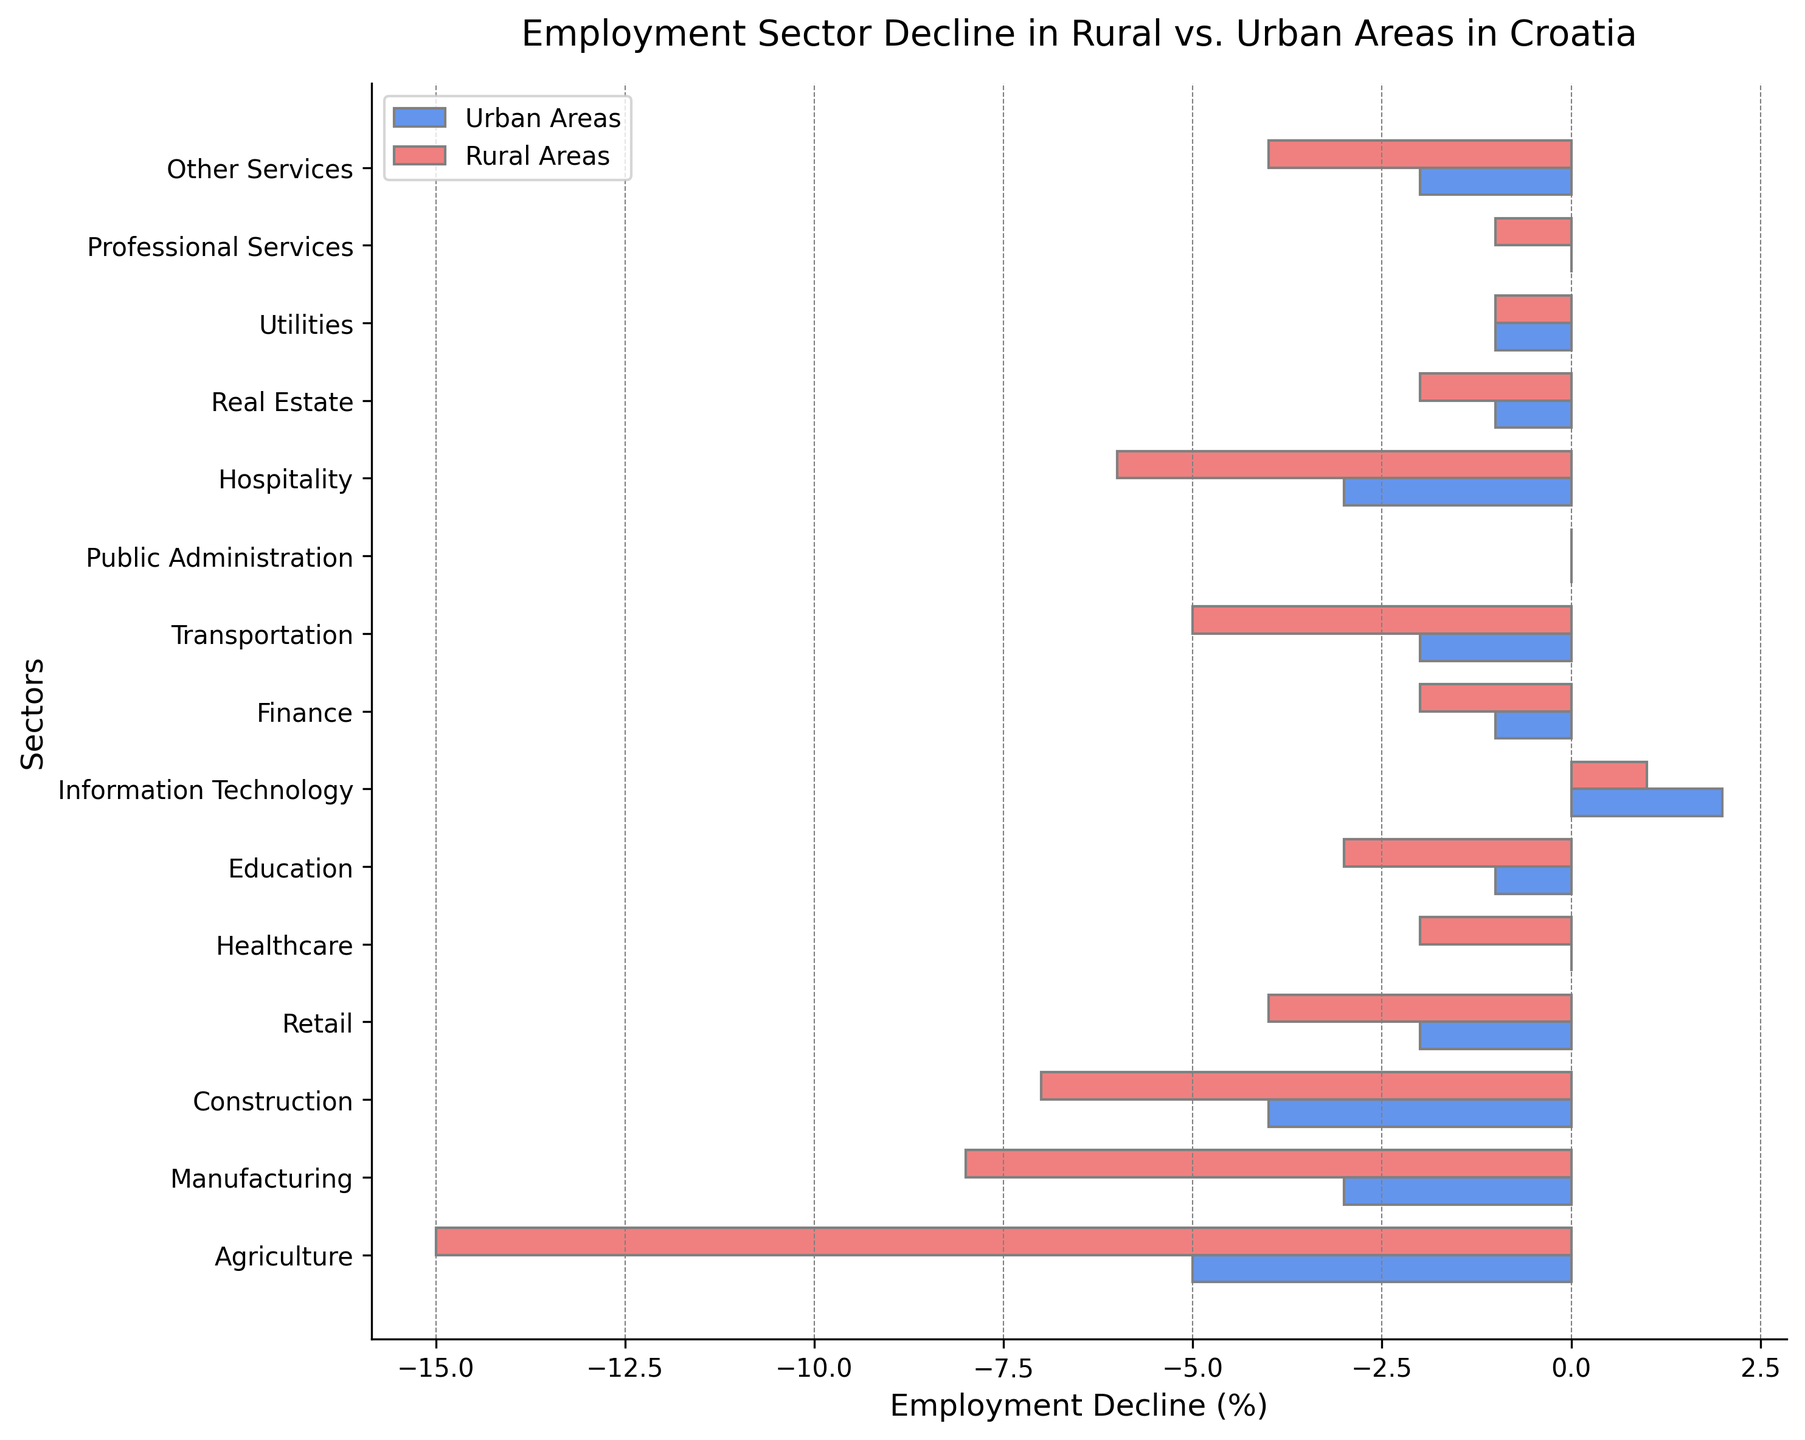What's the total employment decline in Agriculture for both Urban and Rural Areas? To find the total employment decline in Agriculture, add the decline percentages for both Urban and Rural Areas. For Urban Areas, the decline is -5%, and for Rural Areas, the decline is -15%; thus, -5 + (-15) = -20%.
Answer: -20% Which sector has experienced the least decline in Urban Areas and what is its value? In Urban Areas, the sectors with the least (or no) decline are Healthcare, Public Administration, and Information Technology. Healthcare and Public Administration show no decline (0%), but Information Technology shows a positive growth. Thus, they are the sectors with the least decline.
Answer: Healthcare, Public Administration (0%) What is the difference in employment decline between Manufacturing and Construction in Rural Areas? To find the difference in employment decline between Manufacturing and Construction in Rural Areas, subtract the decline of the Construction sector from that of the Manufacturing sector: -8 - (-7) = -8 + 7 = -1%.
Answer: -1% Which sector has shown growth in Information Technology, and what are the growth percentages in Urban and Rural Areas? In the Information Technology sector, there is growth instead of decline. In Urban Areas, it has grown by +2%, and in Rural Areas, it has grown by +1%.
Answer: Urban: +2%, Rural: +1% How many sectors in Rural Areas experienced a decline greater than or equal to 5%? Count the sectors in Rural Areas where the decline is equal to or exceeds 5%. The sectors are Agriculture (-15%), Manufacturing (-8%), Construction (-7%), and Transportation (-5%). Thus, 4 sectors experienced a decline of 5% or more.
Answer: 4 sectors Compare the employment decline in Retail between Urban and Rural Areas; which has a greater decline? Looking at the Retail sector, the decline in Urban Areas is -2%, while in Rural Areas, it is -4%. Therefore, Rural Areas have a greater decline.
Answer: Rural Areas Which sector in Rural Areas shows the highest employment decline and what is its value? The sector with the highest employment decline in Rural Areas is Agriculture, with a decline of -15%.
Answer: Agriculture (-15%) What is the average decline in employment across all sectors in Urban Areas? Sum the decline percentages for all sectors in Urban Areas and divide by the number of sectors: (-5 + -3 + -4 + -2 + 0 + -1 + 2 + -1 + -2 + 0 + -3 + -1 + -1 + 0 + -2) / 15 = -23 / 15 ≈ -1.53%.
Answer: -1.53% Which sector shows no change in employment in both Urban and Rural Areas? Public Administration shows no change in both Urban and Rural Areas, with a decline of 0%.
Answer: Public Administration 